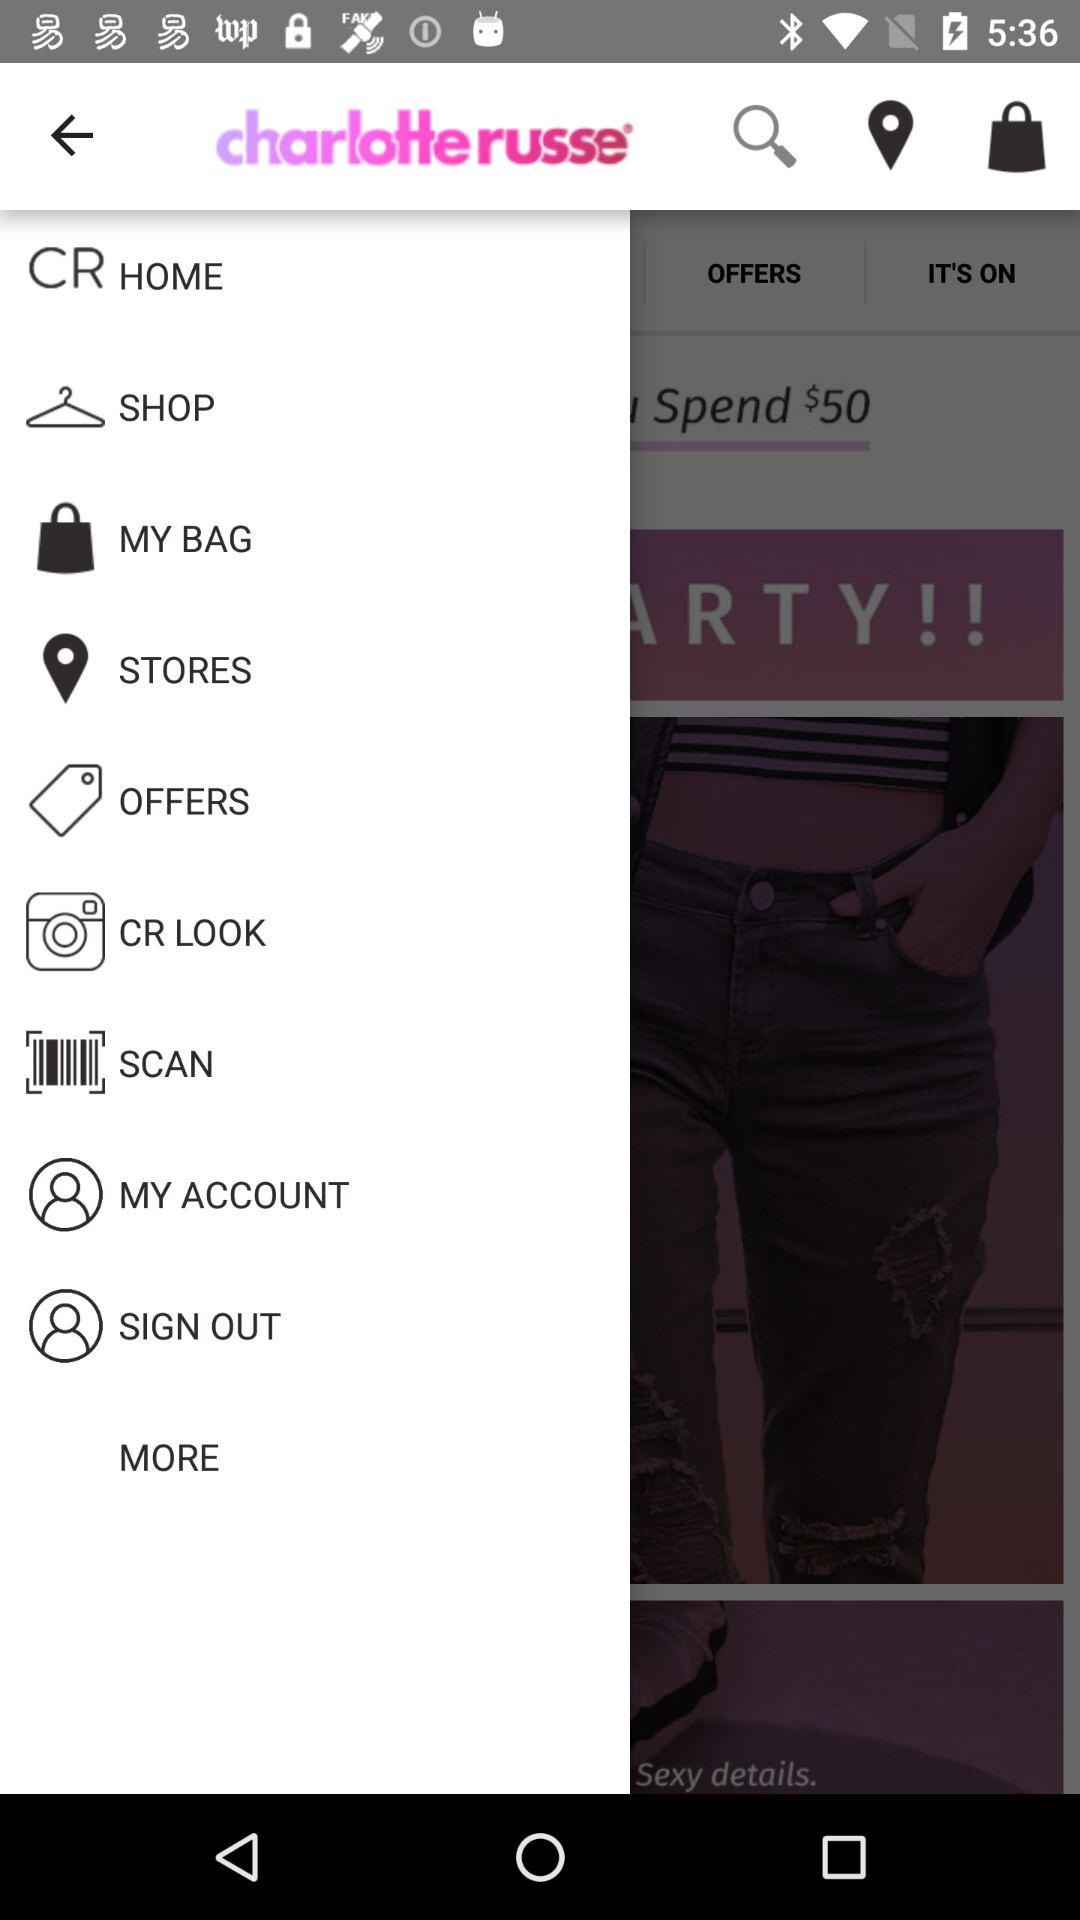What is the name of the application? The name of the application is "charlotte russe". 